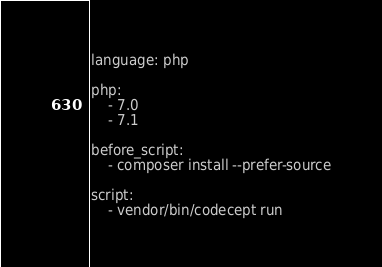Convert code to text. <code><loc_0><loc_0><loc_500><loc_500><_YAML_>language: php

php:
    - 7.0
    - 7.1

before_script:
    - composer install --prefer-source

script:
    - vendor/bin/codecept run
</code> 